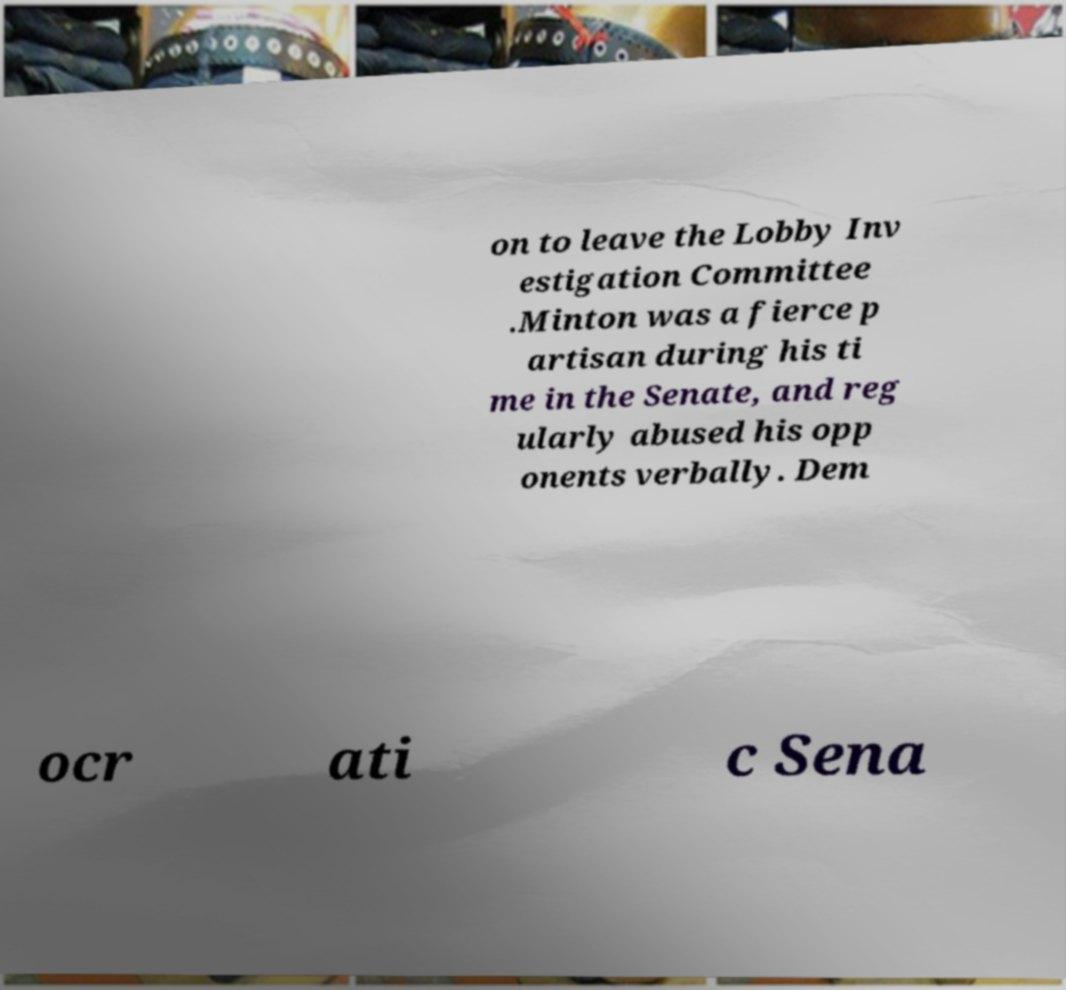Please identify and transcribe the text found in this image. on to leave the Lobby Inv estigation Committee .Minton was a fierce p artisan during his ti me in the Senate, and reg ularly abused his opp onents verbally. Dem ocr ati c Sena 